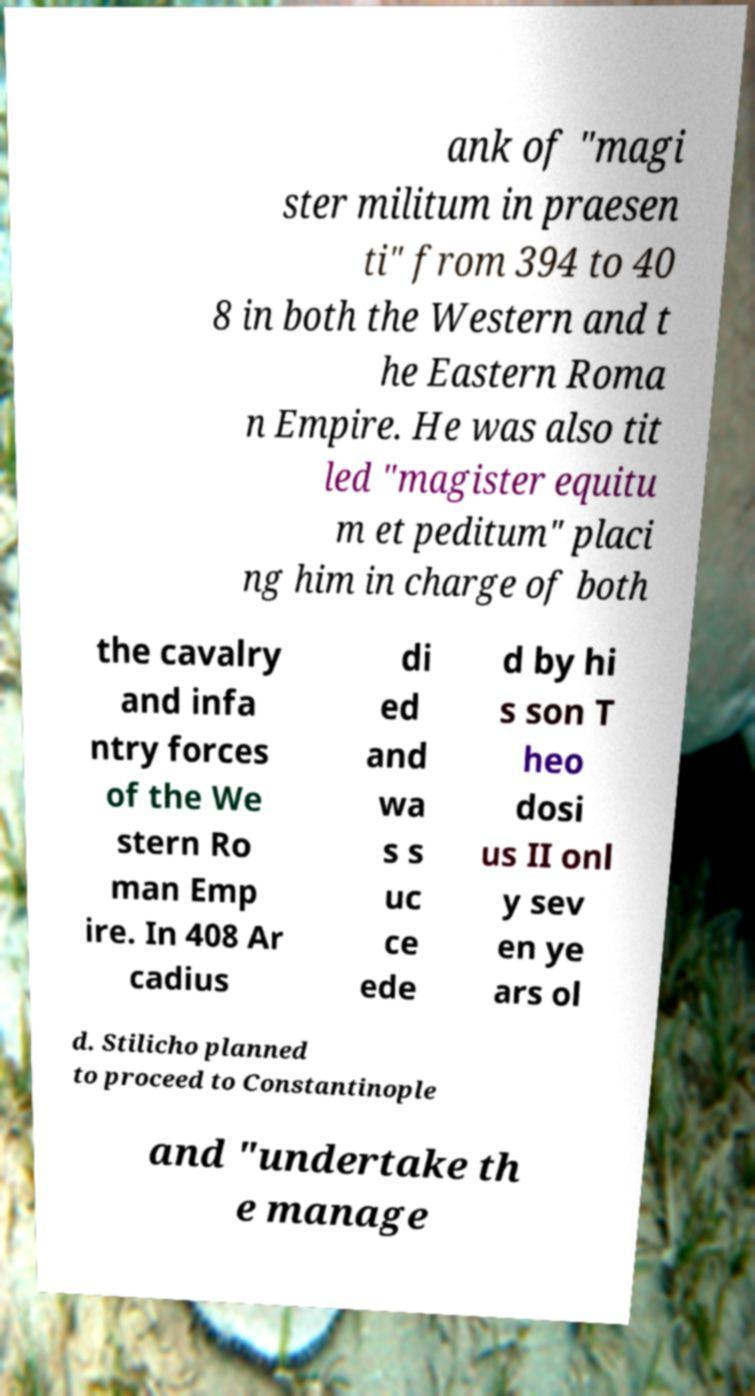Can you read and provide the text displayed in the image?This photo seems to have some interesting text. Can you extract and type it out for me? ank of "magi ster militum in praesen ti" from 394 to 40 8 in both the Western and t he Eastern Roma n Empire. He was also tit led "magister equitu m et peditum" placi ng him in charge of both the cavalry and infa ntry forces of the We stern Ro man Emp ire. In 408 Ar cadius di ed and wa s s uc ce ede d by hi s son T heo dosi us II onl y sev en ye ars ol d. Stilicho planned to proceed to Constantinople and "undertake th e manage 